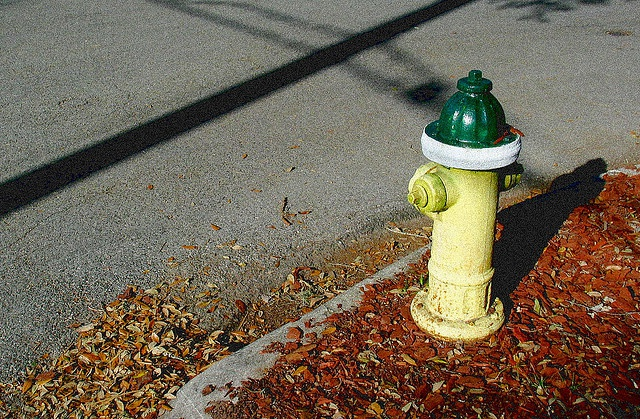Describe the objects in this image and their specific colors. I can see a fire hydrant in gray, khaki, black, and ivory tones in this image. 